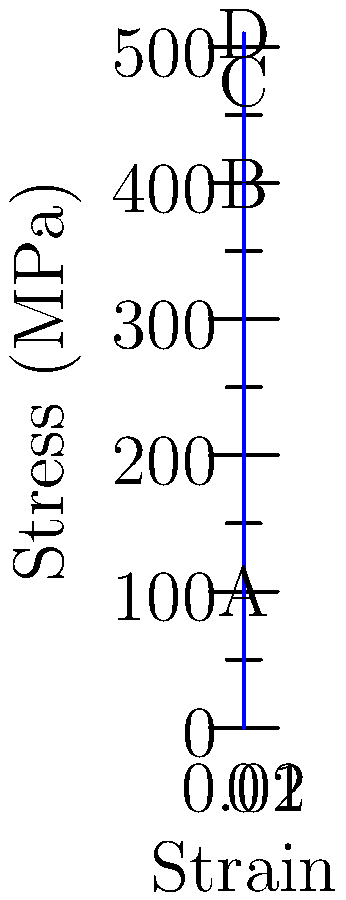Given the stress-strain curve for a steel specimen under tensile loading, calculate the modulus of elasticity (Young's modulus) in GPa between points A and B. How does this value relate to the behavior of the material in this region, and what physical interpretation can be drawn from a particle physics perspective? To solve this problem, we'll follow these steps:

1) Identify the coordinates of points A and B:
   A: (0.002, 100 MPa)
   B: (0.008, 400 MPa)

2) Calculate the change in stress (Δσ) and strain (Δε):
   Δσ = 400 MPa - 100 MPa = 300 MPa
   Δε = 0.008 - 0.002 = 0.006

3) Apply the formula for Young's modulus (E):
   $E = \frac{\Delta\sigma}{\Delta\epsilon}$

4) Substitute the values:
   $E = \frac{300 \text{ MPa}}{0.006} = 50,000 \text{ MPa} = 50 \text{ GPa}$

5) Physical interpretation:
   The linear region between A and B represents the elastic deformation of the material. In this region, the stress is directly proportional to the strain, following Hooke's law. The slope of this line (Young's modulus) quantifies the material's stiffness.

6) Particle physics perspective:
   At the atomic level, the elastic deformation corresponds to small displacements of atoms from their equilibrium positions. The interatomic forces, which can be modeled using quantum mechanics, resist these displacements. The magnitude of Young's modulus is related to the strength of these interatomic bonds.

   In particle physics terms, these interatomic forces are fundamentally electromagnetic interactions between the electron clouds of neighboring atoms. The study of these interactions at the quantum level can provide insights into material properties and behavior under stress.
Answer: 50 GPa; represents material stiffness; reflects strength of interatomic bonds 